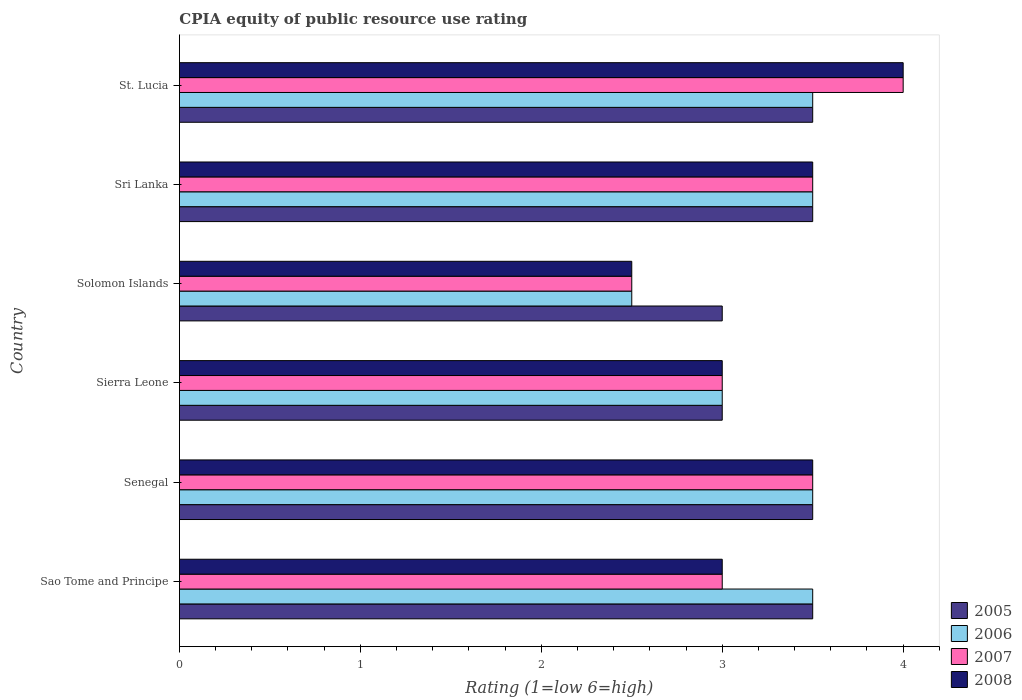How many groups of bars are there?
Provide a short and direct response. 6. What is the label of the 2nd group of bars from the top?
Provide a succinct answer. Sri Lanka. What is the CPIA rating in 2008 in Senegal?
Provide a succinct answer. 3.5. Across all countries, what is the maximum CPIA rating in 2007?
Your answer should be very brief. 4. In which country was the CPIA rating in 2008 maximum?
Make the answer very short. St. Lucia. In which country was the CPIA rating in 2006 minimum?
Offer a terse response. Solomon Islands. What is the total CPIA rating in 2008 in the graph?
Your response must be concise. 19.5. What is the difference between the CPIA rating in 2006 in Senegal and that in Sierra Leone?
Keep it short and to the point. 0.5. What is the difference between the CPIA rating in 2006 in Sri Lanka and the CPIA rating in 2005 in Sao Tome and Principe?
Offer a very short reply. 0. What is the difference between the CPIA rating in 2006 and CPIA rating in 2007 in Senegal?
Provide a short and direct response. 0. What is the ratio of the CPIA rating in 2005 in Sierra Leone to that in Sri Lanka?
Make the answer very short. 0.86. Is the CPIA rating in 2005 in Senegal less than that in Sri Lanka?
Offer a terse response. No. What is the difference between the highest and the second highest CPIA rating in 2008?
Give a very brief answer. 0.5. What is the difference between the highest and the lowest CPIA rating in 2007?
Your answer should be compact. 1.5. In how many countries, is the CPIA rating in 2006 greater than the average CPIA rating in 2006 taken over all countries?
Offer a terse response. 4. Is the sum of the CPIA rating in 2008 in Sierra Leone and Sri Lanka greater than the maximum CPIA rating in 2005 across all countries?
Provide a succinct answer. Yes. Is it the case that in every country, the sum of the CPIA rating in 2007 and CPIA rating in 2006 is greater than the sum of CPIA rating in 2005 and CPIA rating in 2008?
Your answer should be very brief. No. What does the 1st bar from the top in Sao Tome and Principe represents?
Offer a very short reply. 2008. What does the 3rd bar from the bottom in Sao Tome and Principe represents?
Your response must be concise. 2007. How many bars are there?
Keep it short and to the point. 24. Are all the bars in the graph horizontal?
Keep it short and to the point. Yes. Does the graph contain any zero values?
Ensure brevity in your answer.  No. How are the legend labels stacked?
Your answer should be compact. Vertical. What is the title of the graph?
Give a very brief answer. CPIA equity of public resource use rating. What is the label or title of the Y-axis?
Provide a short and direct response. Country. What is the Rating (1=low 6=high) in 2005 in Sao Tome and Principe?
Ensure brevity in your answer.  3.5. What is the Rating (1=low 6=high) in 2008 in Sao Tome and Principe?
Offer a very short reply. 3. What is the Rating (1=low 6=high) in 2008 in Senegal?
Ensure brevity in your answer.  3.5. What is the Rating (1=low 6=high) of 2007 in Sierra Leone?
Your response must be concise. 3. What is the Rating (1=low 6=high) in 2008 in Sierra Leone?
Ensure brevity in your answer.  3. What is the Rating (1=low 6=high) in 2006 in Solomon Islands?
Provide a short and direct response. 2.5. What is the Rating (1=low 6=high) in 2005 in Sri Lanka?
Keep it short and to the point. 3.5. What is the Rating (1=low 6=high) of 2008 in Sri Lanka?
Your response must be concise. 3.5. What is the Rating (1=low 6=high) in 2005 in St. Lucia?
Make the answer very short. 3.5. Across all countries, what is the maximum Rating (1=low 6=high) of 2005?
Your answer should be compact. 3.5. Across all countries, what is the maximum Rating (1=low 6=high) of 2006?
Keep it short and to the point. 3.5. Across all countries, what is the maximum Rating (1=low 6=high) in 2008?
Offer a very short reply. 4. Across all countries, what is the minimum Rating (1=low 6=high) in 2007?
Your answer should be compact. 2.5. Across all countries, what is the minimum Rating (1=low 6=high) in 2008?
Provide a short and direct response. 2.5. What is the total Rating (1=low 6=high) of 2005 in the graph?
Ensure brevity in your answer.  20. What is the total Rating (1=low 6=high) in 2006 in the graph?
Provide a succinct answer. 19.5. What is the total Rating (1=low 6=high) in 2007 in the graph?
Your answer should be very brief. 19.5. What is the difference between the Rating (1=low 6=high) of 2006 in Sao Tome and Principe and that in Senegal?
Give a very brief answer. 0. What is the difference between the Rating (1=low 6=high) in 2005 in Sao Tome and Principe and that in Sierra Leone?
Keep it short and to the point. 0.5. What is the difference between the Rating (1=low 6=high) of 2006 in Sao Tome and Principe and that in Sierra Leone?
Your answer should be compact. 0.5. What is the difference between the Rating (1=low 6=high) in 2008 in Sao Tome and Principe and that in Sierra Leone?
Your answer should be compact. 0. What is the difference between the Rating (1=low 6=high) in 2006 in Sao Tome and Principe and that in Solomon Islands?
Keep it short and to the point. 1. What is the difference between the Rating (1=low 6=high) of 2008 in Sao Tome and Principe and that in Solomon Islands?
Your response must be concise. 0.5. What is the difference between the Rating (1=low 6=high) in 2005 in Sao Tome and Principe and that in Sri Lanka?
Your response must be concise. 0. What is the difference between the Rating (1=low 6=high) of 2007 in Sao Tome and Principe and that in Sri Lanka?
Your response must be concise. -0.5. What is the difference between the Rating (1=low 6=high) of 2008 in Sao Tome and Principe and that in Sri Lanka?
Your answer should be compact. -0.5. What is the difference between the Rating (1=low 6=high) in 2007 in Sao Tome and Principe and that in St. Lucia?
Give a very brief answer. -1. What is the difference between the Rating (1=low 6=high) in 2008 in Sao Tome and Principe and that in St. Lucia?
Offer a terse response. -1. What is the difference between the Rating (1=low 6=high) in 2006 in Senegal and that in Sierra Leone?
Provide a succinct answer. 0.5. What is the difference between the Rating (1=low 6=high) of 2006 in Senegal and that in Solomon Islands?
Your response must be concise. 1. What is the difference between the Rating (1=low 6=high) in 2008 in Senegal and that in Solomon Islands?
Offer a terse response. 1. What is the difference between the Rating (1=low 6=high) of 2005 in Senegal and that in Sri Lanka?
Offer a terse response. 0. What is the difference between the Rating (1=low 6=high) of 2006 in Senegal and that in Sri Lanka?
Give a very brief answer. 0. What is the difference between the Rating (1=low 6=high) of 2007 in Senegal and that in Sri Lanka?
Provide a succinct answer. 0. What is the difference between the Rating (1=low 6=high) of 2005 in Senegal and that in St. Lucia?
Give a very brief answer. 0. What is the difference between the Rating (1=low 6=high) in 2007 in Senegal and that in St. Lucia?
Offer a terse response. -0.5. What is the difference between the Rating (1=low 6=high) of 2008 in Senegal and that in St. Lucia?
Provide a succinct answer. -0.5. What is the difference between the Rating (1=low 6=high) of 2006 in Sierra Leone and that in Solomon Islands?
Give a very brief answer. 0.5. What is the difference between the Rating (1=low 6=high) of 2007 in Sierra Leone and that in Solomon Islands?
Your response must be concise. 0.5. What is the difference between the Rating (1=low 6=high) of 2008 in Sierra Leone and that in Solomon Islands?
Provide a short and direct response. 0.5. What is the difference between the Rating (1=low 6=high) in 2007 in Sierra Leone and that in Sri Lanka?
Your response must be concise. -0.5. What is the difference between the Rating (1=low 6=high) in 2008 in Sierra Leone and that in Sri Lanka?
Provide a short and direct response. -0.5. What is the difference between the Rating (1=low 6=high) in 2005 in Sierra Leone and that in St. Lucia?
Give a very brief answer. -0.5. What is the difference between the Rating (1=low 6=high) in 2006 in Sierra Leone and that in St. Lucia?
Give a very brief answer. -0.5. What is the difference between the Rating (1=low 6=high) in 2007 in Sierra Leone and that in St. Lucia?
Make the answer very short. -1. What is the difference between the Rating (1=low 6=high) in 2008 in Sierra Leone and that in St. Lucia?
Offer a terse response. -1. What is the difference between the Rating (1=low 6=high) in 2005 in Solomon Islands and that in Sri Lanka?
Offer a terse response. -0.5. What is the difference between the Rating (1=low 6=high) in 2008 in Solomon Islands and that in Sri Lanka?
Provide a short and direct response. -1. What is the difference between the Rating (1=low 6=high) of 2005 in Solomon Islands and that in St. Lucia?
Your response must be concise. -0.5. What is the difference between the Rating (1=low 6=high) of 2006 in Solomon Islands and that in St. Lucia?
Keep it short and to the point. -1. What is the difference between the Rating (1=low 6=high) of 2008 in Sri Lanka and that in St. Lucia?
Ensure brevity in your answer.  -0.5. What is the difference between the Rating (1=low 6=high) of 2005 in Sao Tome and Principe and the Rating (1=low 6=high) of 2008 in Senegal?
Offer a very short reply. 0. What is the difference between the Rating (1=low 6=high) of 2006 in Sao Tome and Principe and the Rating (1=low 6=high) of 2007 in Senegal?
Give a very brief answer. 0. What is the difference between the Rating (1=low 6=high) of 2007 in Sao Tome and Principe and the Rating (1=low 6=high) of 2008 in Senegal?
Offer a very short reply. -0.5. What is the difference between the Rating (1=low 6=high) of 2005 in Sao Tome and Principe and the Rating (1=low 6=high) of 2006 in Sierra Leone?
Ensure brevity in your answer.  0.5. What is the difference between the Rating (1=low 6=high) of 2006 in Sao Tome and Principe and the Rating (1=low 6=high) of 2007 in Sierra Leone?
Provide a short and direct response. 0.5. What is the difference between the Rating (1=low 6=high) in 2007 in Sao Tome and Principe and the Rating (1=low 6=high) in 2008 in Sierra Leone?
Offer a terse response. 0. What is the difference between the Rating (1=low 6=high) of 2005 in Sao Tome and Principe and the Rating (1=low 6=high) of 2006 in Solomon Islands?
Offer a very short reply. 1. What is the difference between the Rating (1=low 6=high) in 2005 in Sao Tome and Principe and the Rating (1=low 6=high) in 2007 in Solomon Islands?
Offer a very short reply. 1. What is the difference between the Rating (1=low 6=high) of 2006 in Sao Tome and Principe and the Rating (1=low 6=high) of 2007 in Solomon Islands?
Give a very brief answer. 1. What is the difference between the Rating (1=low 6=high) of 2005 in Sao Tome and Principe and the Rating (1=low 6=high) of 2008 in Sri Lanka?
Your answer should be very brief. 0. What is the difference between the Rating (1=low 6=high) of 2006 in Sao Tome and Principe and the Rating (1=low 6=high) of 2008 in Sri Lanka?
Make the answer very short. 0. What is the difference between the Rating (1=low 6=high) of 2007 in Sao Tome and Principe and the Rating (1=low 6=high) of 2008 in Sri Lanka?
Your answer should be compact. -0.5. What is the difference between the Rating (1=low 6=high) of 2005 in Sao Tome and Principe and the Rating (1=low 6=high) of 2006 in St. Lucia?
Your answer should be very brief. 0. What is the difference between the Rating (1=low 6=high) of 2005 in Sao Tome and Principe and the Rating (1=low 6=high) of 2007 in St. Lucia?
Provide a succinct answer. -0.5. What is the difference between the Rating (1=low 6=high) of 2005 in Sao Tome and Principe and the Rating (1=low 6=high) of 2008 in St. Lucia?
Offer a terse response. -0.5. What is the difference between the Rating (1=low 6=high) of 2006 in Sao Tome and Principe and the Rating (1=low 6=high) of 2007 in St. Lucia?
Offer a very short reply. -0.5. What is the difference between the Rating (1=low 6=high) in 2006 in Sao Tome and Principe and the Rating (1=low 6=high) in 2008 in St. Lucia?
Your answer should be compact. -0.5. What is the difference between the Rating (1=low 6=high) in 2007 in Sao Tome and Principe and the Rating (1=low 6=high) in 2008 in St. Lucia?
Give a very brief answer. -1. What is the difference between the Rating (1=low 6=high) in 2005 in Senegal and the Rating (1=low 6=high) in 2008 in Sierra Leone?
Your answer should be compact. 0.5. What is the difference between the Rating (1=low 6=high) in 2007 in Senegal and the Rating (1=low 6=high) in 2008 in Sierra Leone?
Offer a terse response. 0.5. What is the difference between the Rating (1=low 6=high) in 2005 in Senegal and the Rating (1=low 6=high) in 2006 in Solomon Islands?
Your response must be concise. 1. What is the difference between the Rating (1=low 6=high) in 2005 in Senegal and the Rating (1=low 6=high) in 2007 in Solomon Islands?
Keep it short and to the point. 1. What is the difference between the Rating (1=low 6=high) in 2006 in Senegal and the Rating (1=low 6=high) in 2008 in Solomon Islands?
Provide a short and direct response. 1. What is the difference between the Rating (1=low 6=high) of 2005 in Senegal and the Rating (1=low 6=high) of 2006 in Sri Lanka?
Your answer should be compact. 0. What is the difference between the Rating (1=low 6=high) of 2005 in Senegal and the Rating (1=low 6=high) of 2007 in Sri Lanka?
Provide a short and direct response. 0. What is the difference between the Rating (1=low 6=high) in 2005 in Senegal and the Rating (1=low 6=high) in 2006 in St. Lucia?
Offer a very short reply. 0. What is the difference between the Rating (1=low 6=high) in 2005 in Senegal and the Rating (1=low 6=high) in 2008 in St. Lucia?
Offer a terse response. -0.5. What is the difference between the Rating (1=low 6=high) of 2006 in Senegal and the Rating (1=low 6=high) of 2007 in St. Lucia?
Offer a terse response. -0.5. What is the difference between the Rating (1=low 6=high) of 2005 in Sierra Leone and the Rating (1=low 6=high) of 2007 in Solomon Islands?
Keep it short and to the point. 0.5. What is the difference between the Rating (1=low 6=high) in 2005 in Sierra Leone and the Rating (1=low 6=high) in 2008 in Solomon Islands?
Offer a terse response. 0.5. What is the difference between the Rating (1=low 6=high) of 2006 in Sierra Leone and the Rating (1=low 6=high) of 2008 in Solomon Islands?
Your answer should be very brief. 0.5. What is the difference between the Rating (1=low 6=high) of 2006 in Sierra Leone and the Rating (1=low 6=high) of 2007 in Sri Lanka?
Provide a succinct answer. -0.5. What is the difference between the Rating (1=low 6=high) in 2006 in Sierra Leone and the Rating (1=low 6=high) in 2008 in Sri Lanka?
Offer a very short reply. -0.5. What is the difference between the Rating (1=low 6=high) of 2006 in Sierra Leone and the Rating (1=low 6=high) of 2007 in St. Lucia?
Give a very brief answer. -1. What is the difference between the Rating (1=low 6=high) of 2006 in Sierra Leone and the Rating (1=low 6=high) of 2008 in St. Lucia?
Your response must be concise. -1. What is the difference between the Rating (1=low 6=high) in 2005 in Solomon Islands and the Rating (1=low 6=high) in 2007 in Sri Lanka?
Offer a very short reply. -0.5. What is the difference between the Rating (1=low 6=high) of 2006 in Solomon Islands and the Rating (1=low 6=high) of 2007 in Sri Lanka?
Offer a very short reply. -1. What is the difference between the Rating (1=low 6=high) of 2005 in Solomon Islands and the Rating (1=low 6=high) of 2006 in St. Lucia?
Provide a short and direct response. -0.5. What is the difference between the Rating (1=low 6=high) in 2006 in Solomon Islands and the Rating (1=low 6=high) in 2007 in St. Lucia?
Keep it short and to the point. -1.5. What is the difference between the Rating (1=low 6=high) in 2007 in Solomon Islands and the Rating (1=low 6=high) in 2008 in St. Lucia?
Provide a short and direct response. -1.5. What is the difference between the Rating (1=low 6=high) in 2006 in Sri Lanka and the Rating (1=low 6=high) in 2007 in St. Lucia?
Offer a terse response. -0.5. What is the difference between the Rating (1=low 6=high) in 2007 in Sri Lanka and the Rating (1=low 6=high) in 2008 in St. Lucia?
Your answer should be compact. -0.5. What is the average Rating (1=low 6=high) in 2005 per country?
Provide a short and direct response. 3.33. What is the difference between the Rating (1=low 6=high) of 2005 and Rating (1=low 6=high) of 2006 in Sao Tome and Principe?
Offer a very short reply. 0. What is the difference between the Rating (1=low 6=high) of 2005 and Rating (1=low 6=high) of 2007 in Sao Tome and Principe?
Give a very brief answer. 0.5. What is the difference between the Rating (1=low 6=high) in 2005 and Rating (1=low 6=high) in 2008 in Sao Tome and Principe?
Ensure brevity in your answer.  0.5. What is the difference between the Rating (1=low 6=high) of 2006 and Rating (1=low 6=high) of 2008 in Sao Tome and Principe?
Make the answer very short. 0.5. What is the difference between the Rating (1=low 6=high) of 2005 and Rating (1=low 6=high) of 2006 in Senegal?
Your answer should be very brief. 0. What is the difference between the Rating (1=low 6=high) in 2005 and Rating (1=low 6=high) in 2007 in Senegal?
Your response must be concise. 0. What is the difference between the Rating (1=low 6=high) in 2005 and Rating (1=low 6=high) in 2008 in Senegal?
Provide a succinct answer. 0. What is the difference between the Rating (1=low 6=high) of 2006 and Rating (1=low 6=high) of 2007 in Senegal?
Ensure brevity in your answer.  0. What is the difference between the Rating (1=low 6=high) of 2007 and Rating (1=low 6=high) of 2008 in Senegal?
Provide a succinct answer. 0. What is the difference between the Rating (1=low 6=high) of 2005 and Rating (1=low 6=high) of 2007 in Sierra Leone?
Your response must be concise. 0. What is the difference between the Rating (1=low 6=high) in 2005 and Rating (1=low 6=high) in 2008 in Sierra Leone?
Ensure brevity in your answer.  0. What is the difference between the Rating (1=low 6=high) of 2006 and Rating (1=low 6=high) of 2008 in Sierra Leone?
Your response must be concise. 0. What is the difference between the Rating (1=low 6=high) of 2005 and Rating (1=low 6=high) of 2006 in Solomon Islands?
Ensure brevity in your answer.  0.5. What is the difference between the Rating (1=low 6=high) of 2005 and Rating (1=low 6=high) of 2007 in Sri Lanka?
Offer a terse response. 0. What is the difference between the Rating (1=low 6=high) in 2005 and Rating (1=low 6=high) in 2008 in Sri Lanka?
Ensure brevity in your answer.  0. What is the difference between the Rating (1=low 6=high) of 2005 and Rating (1=low 6=high) of 2006 in St. Lucia?
Keep it short and to the point. 0. What is the difference between the Rating (1=low 6=high) of 2005 and Rating (1=low 6=high) of 2007 in St. Lucia?
Provide a succinct answer. -0.5. What is the difference between the Rating (1=low 6=high) in 2005 and Rating (1=low 6=high) in 2008 in St. Lucia?
Provide a succinct answer. -0.5. What is the difference between the Rating (1=low 6=high) in 2006 and Rating (1=low 6=high) in 2007 in St. Lucia?
Provide a short and direct response. -0.5. What is the difference between the Rating (1=low 6=high) in 2006 and Rating (1=low 6=high) in 2008 in St. Lucia?
Offer a terse response. -0.5. What is the difference between the Rating (1=low 6=high) of 2007 and Rating (1=low 6=high) of 2008 in St. Lucia?
Give a very brief answer. 0. What is the ratio of the Rating (1=low 6=high) in 2005 in Sao Tome and Principe to that in Senegal?
Ensure brevity in your answer.  1. What is the ratio of the Rating (1=low 6=high) in 2007 in Sao Tome and Principe to that in Senegal?
Your answer should be compact. 0.86. What is the ratio of the Rating (1=low 6=high) in 2006 in Sao Tome and Principe to that in Sierra Leone?
Provide a succinct answer. 1.17. What is the ratio of the Rating (1=low 6=high) in 2007 in Sao Tome and Principe to that in Solomon Islands?
Offer a terse response. 1.2. What is the ratio of the Rating (1=low 6=high) in 2005 in Sao Tome and Principe to that in Sri Lanka?
Keep it short and to the point. 1. What is the ratio of the Rating (1=low 6=high) in 2006 in Sao Tome and Principe to that in Sri Lanka?
Offer a terse response. 1. What is the ratio of the Rating (1=low 6=high) in 2007 in Senegal to that in Sierra Leone?
Give a very brief answer. 1.17. What is the ratio of the Rating (1=low 6=high) of 2005 in Senegal to that in Solomon Islands?
Your answer should be very brief. 1.17. What is the ratio of the Rating (1=low 6=high) of 2006 in Senegal to that in Solomon Islands?
Your answer should be compact. 1.4. What is the ratio of the Rating (1=low 6=high) in 2007 in Senegal to that in Solomon Islands?
Offer a terse response. 1.4. What is the ratio of the Rating (1=low 6=high) in 2007 in Senegal to that in Sri Lanka?
Provide a short and direct response. 1. What is the ratio of the Rating (1=low 6=high) of 2006 in Senegal to that in St. Lucia?
Ensure brevity in your answer.  1. What is the ratio of the Rating (1=low 6=high) in 2007 in Senegal to that in St. Lucia?
Keep it short and to the point. 0.88. What is the ratio of the Rating (1=low 6=high) of 2006 in Sierra Leone to that in Solomon Islands?
Offer a terse response. 1.2. What is the ratio of the Rating (1=low 6=high) of 2007 in Sierra Leone to that in Solomon Islands?
Your answer should be very brief. 1.2. What is the ratio of the Rating (1=low 6=high) of 2008 in Sierra Leone to that in Solomon Islands?
Provide a succinct answer. 1.2. What is the ratio of the Rating (1=low 6=high) in 2005 in Sierra Leone to that in Sri Lanka?
Offer a very short reply. 0.86. What is the ratio of the Rating (1=low 6=high) of 2006 in Sierra Leone to that in Sri Lanka?
Provide a short and direct response. 0.86. What is the ratio of the Rating (1=low 6=high) in 2007 in Sierra Leone to that in Sri Lanka?
Provide a short and direct response. 0.86. What is the ratio of the Rating (1=low 6=high) of 2008 in Sierra Leone to that in Sri Lanka?
Offer a terse response. 0.86. What is the ratio of the Rating (1=low 6=high) in 2006 in Sierra Leone to that in St. Lucia?
Your answer should be compact. 0.86. What is the ratio of the Rating (1=low 6=high) in 2007 in Sierra Leone to that in St. Lucia?
Ensure brevity in your answer.  0.75. What is the ratio of the Rating (1=low 6=high) of 2008 in Sierra Leone to that in St. Lucia?
Provide a succinct answer. 0.75. What is the ratio of the Rating (1=low 6=high) of 2005 in Solomon Islands to that in Sri Lanka?
Ensure brevity in your answer.  0.86. What is the ratio of the Rating (1=low 6=high) in 2006 in Solomon Islands to that in Sri Lanka?
Provide a succinct answer. 0.71. What is the ratio of the Rating (1=low 6=high) of 2006 in Solomon Islands to that in St. Lucia?
Provide a short and direct response. 0.71. What is the ratio of the Rating (1=low 6=high) in 2007 in Solomon Islands to that in St. Lucia?
Provide a succinct answer. 0.62. What is the ratio of the Rating (1=low 6=high) in 2008 in Solomon Islands to that in St. Lucia?
Your answer should be very brief. 0.62. What is the ratio of the Rating (1=low 6=high) of 2005 in Sri Lanka to that in St. Lucia?
Keep it short and to the point. 1. What is the ratio of the Rating (1=low 6=high) in 2007 in Sri Lanka to that in St. Lucia?
Offer a terse response. 0.88. What is the difference between the highest and the lowest Rating (1=low 6=high) in 2005?
Provide a short and direct response. 0.5. What is the difference between the highest and the lowest Rating (1=low 6=high) in 2006?
Provide a short and direct response. 1. What is the difference between the highest and the lowest Rating (1=low 6=high) in 2007?
Your answer should be very brief. 1.5. What is the difference between the highest and the lowest Rating (1=low 6=high) in 2008?
Offer a very short reply. 1.5. 